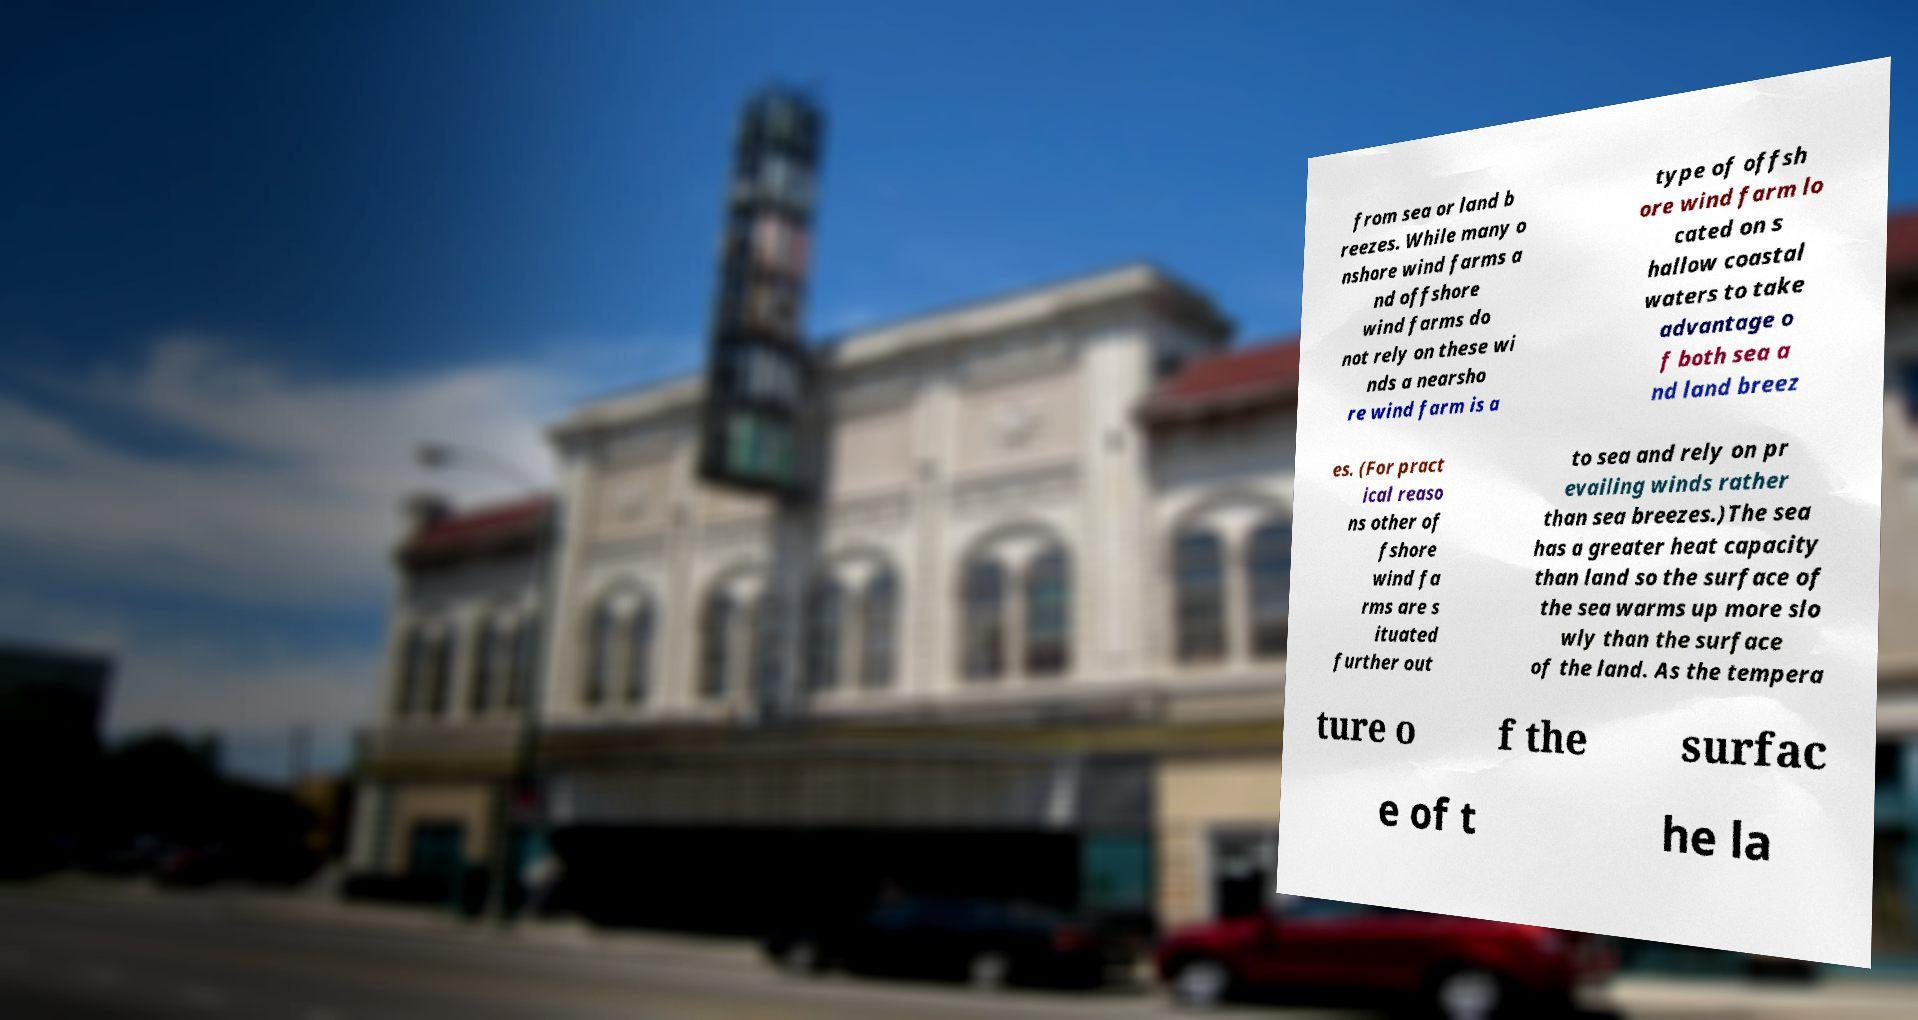What messages or text are displayed in this image? I need them in a readable, typed format. from sea or land b reezes. While many o nshore wind farms a nd offshore wind farms do not rely on these wi nds a nearsho re wind farm is a type of offsh ore wind farm lo cated on s hallow coastal waters to take advantage o f both sea a nd land breez es. (For pract ical reaso ns other of fshore wind fa rms are s ituated further out to sea and rely on pr evailing winds rather than sea breezes.)The sea has a greater heat capacity than land so the surface of the sea warms up more slo wly than the surface of the land. As the tempera ture o f the surfac e of t he la 